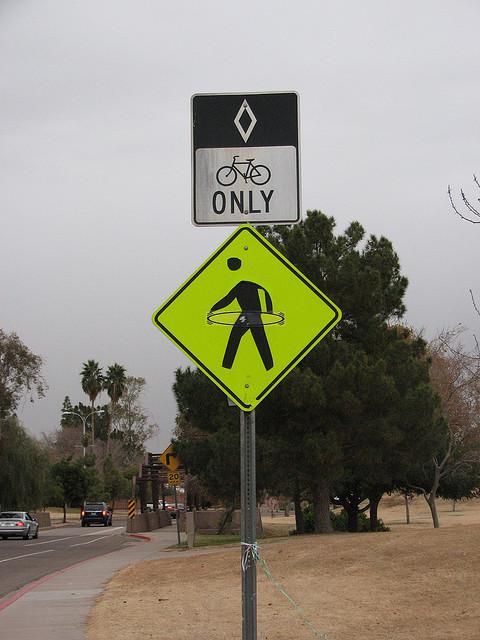Is there an icon of a man on a neon sign?
Write a very short answer. Yes. What street sign is pictured?
Give a very brief answer. Crosswalk and bike only. What color is the sign?
Short answer required. Yellow. What does the yellow sign say?
Quick response, please. Pedestrian. Is the sky gray?
Short answer required. Yes. Is there snow on the ground?
Keep it brief. No. What words are on the sign?
Be succinct. Only. How many cars are in the picture?
Short answer required. 2. Is the grass green?
Concise answer only. No. What does the sign say?
Answer briefly. Only. What does the left sign say?
Short answer required. Only. What is written on the sign?
Keep it brief. Only. 